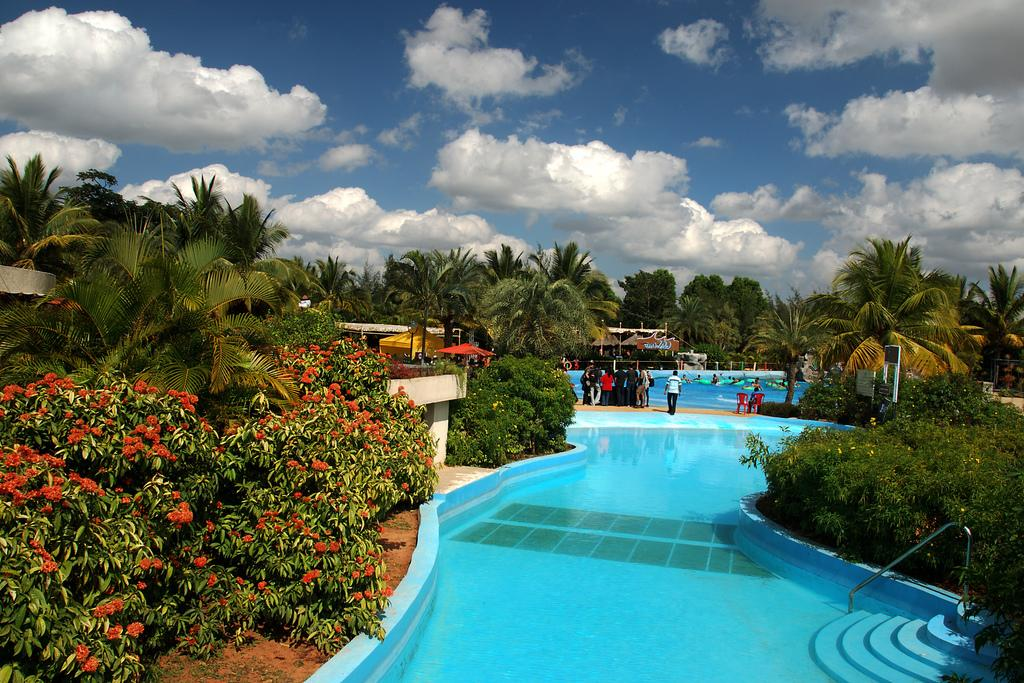What type of water features are present in the image? There are pools in the image. Can you describe the people in the image? There are people in the image. What other natural elements can be seen in the image? There are plants and flowers in the image. What can be seen in the background of the image? There are trees, buildings, and the sky visible in the background of the image. How many monkeys are sitting on the trees in the image? There are no monkeys present in the image; it features pools, people, plants, flowers, trees, buildings, and the sky. What is the amount of wind blowing in the image? There is no mention of wind in the image, so it cannot be determined from the provided facts. 